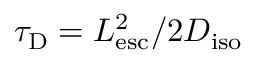<formula> <loc_0><loc_0><loc_500><loc_500>\tau _ { D } = L _ { e s c } ^ { 2 } / 2 D _ { i s o }</formula> 